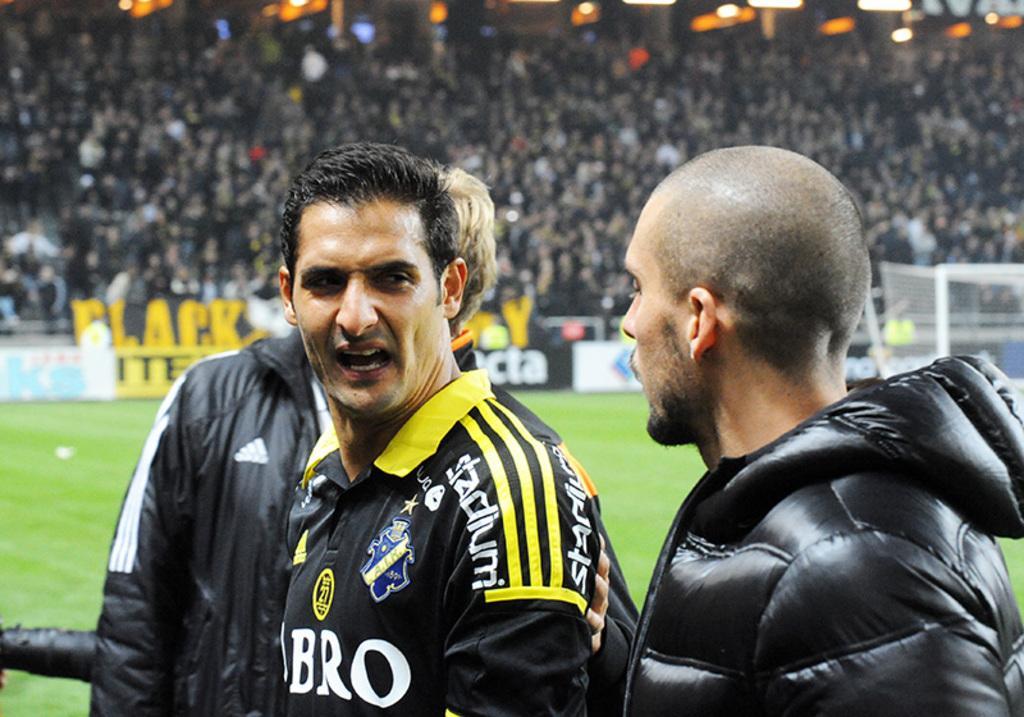Could you give a brief overview of what you see in this image? In the foreground of the picture there are three men. This is a picture taken in a stadium. In the center of the picture it is football ground. At the top there are audience and lights. 